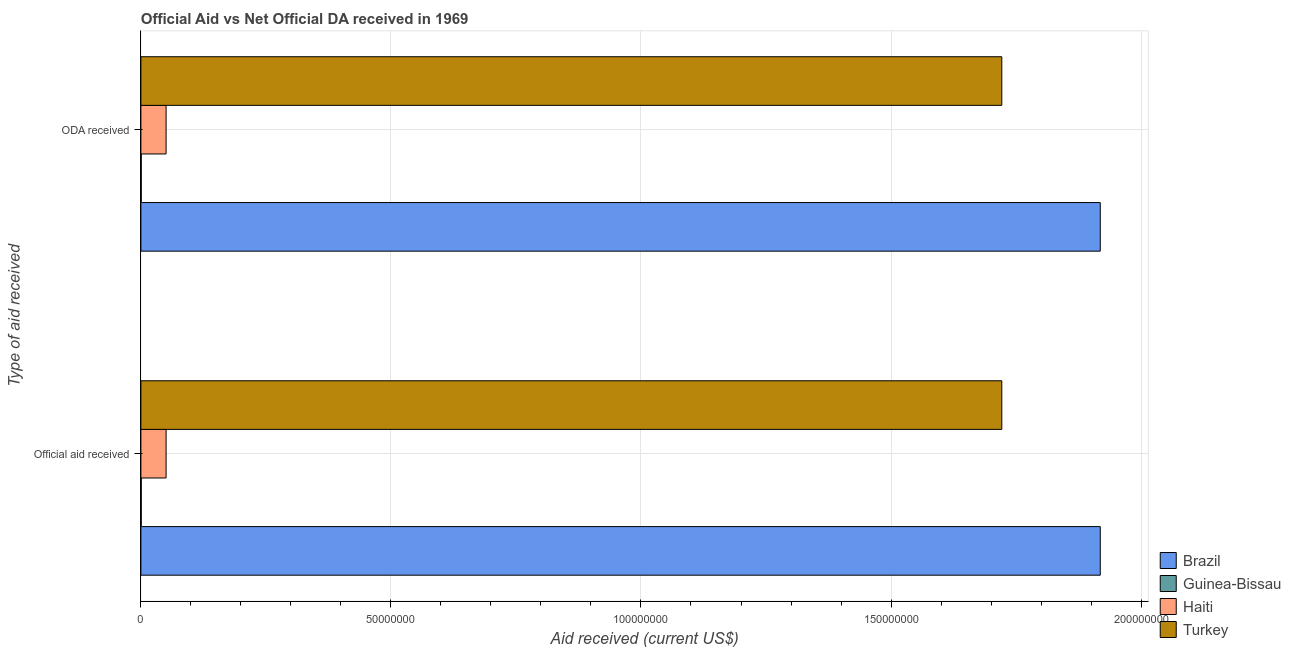How many different coloured bars are there?
Your response must be concise. 4. How many groups of bars are there?
Keep it short and to the point. 2. What is the label of the 2nd group of bars from the top?
Make the answer very short. Official aid received. What is the official aid received in Turkey?
Offer a very short reply. 1.72e+08. Across all countries, what is the maximum oda received?
Keep it short and to the point. 1.92e+08. Across all countries, what is the minimum official aid received?
Offer a very short reply. 7.00e+04. In which country was the oda received minimum?
Your response must be concise. Guinea-Bissau. What is the total oda received in the graph?
Keep it short and to the point. 3.69e+08. What is the difference between the official aid received in Guinea-Bissau and that in Brazil?
Your response must be concise. -1.92e+08. What is the difference between the oda received in Brazil and the official aid received in Haiti?
Your answer should be very brief. 1.87e+08. What is the average official aid received per country?
Offer a very short reply. 9.23e+07. In how many countries, is the oda received greater than 40000000 US$?
Your response must be concise. 2. What is the ratio of the official aid received in Turkey to that in Guinea-Bissau?
Provide a short and direct response. 2459.29. What does the 3rd bar from the top in ODA received represents?
Give a very brief answer. Guinea-Bissau. What does the 3rd bar from the bottom in ODA received represents?
Offer a very short reply. Haiti. How many bars are there?
Ensure brevity in your answer.  8. Are all the bars in the graph horizontal?
Make the answer very short. Yes. Does the graph contain grids?
Your answer should be very brief. Yes. Where does the legend appear in the graph?
Make the answer very short. Bottom right. How many legend labels are there?
Ensure brevity in your answer.  4. What is the title of the graph?
Ensure brevity in your answer.  Official Aid vs Net Official DA received in 1969 . Does "Uzbekistan" appear as one of the legend labels in the graph?
Your answer should be very brief. No. What is the label or title of the X-axis?
Give a very brief answer. Aid received (current US$). What is the label or title of the Y-axis?
Offer a very short reply. Type of aid received. What is the Aid received (current US$) of Brazil in Official aid received?
Provide a short and direct response. 1.92e+08. What is the Aid received (current US$) in Haiti in Official aid received?
Offer a terse response. 5.04e+06. What is the Aid received (current US$) in Turkey in Official aid received?
Your answer should be very brief. 1.72e+08. What is the Aid received (current US$) in Brazil in ODA received?
Your answer should be very brief. 1.92e+08. What is the Aid received (current US$) of Guinea-Bissau in ODA received?
Your response must be concise. 7.00e+04. What is the Aid received (current US$) of Haiti in ODA received?
Offer a very short reply. 5.04e+06. What is the Aid received (current US$) in Turkey in ODA received?
Your response must be concise. 1.72e+08. Across all Type of aid received, what is the maximum Aid received (current US$) in Brazil?
Give a very brief answer. 1.92e+08. Across all Type of aid received, what is the maximum Aid received (current US$) of Haiti?
Your answer should be very brief. 5.04e+06. Across all Type of aid received, what is the maximum Aid received (current US$) of Turkey?
Keep it short and to the point. 1.72e+08. Across all Type of aid received, what is the minimum Aid received (current US$) of Brazil?
Provide a short and direct response. 1.92e+08. Across all Type of aid received, what is the minimum Aid received (current US$) in Haiti?
Your response must be concise. 5.04e+06. Across all Type of aid received, what is the minimum Aid received (current US$) in Turkey?
Provide a succinct answer. 1.72e+08. What is the total Aid received (current US$) in Brazil in the graph?
Offer a terse response. 3.84e+08. What is the total Aid received (current US$) in Guinea-Bissau in the graph?
Your answer should be compact. 1.40e+05. What is the total Aid received (current US$) in Haiti in the graph?
Offer a very short reply. 1.01e+07. What is the total Aid received (current US$) of Turkey in the graph?
Your response must be concise. 3.44e+08. What is the difference between the Aid received (current US$) in Haiti in Official aid received and that in ODA received?
Ensure brevity in your answer.  0. What is the difference between the Aid received (current US$) in Brazil in Official aid received and the Aid received (current US$) in Guinea-Bissau in ODA received?
Keep it short and to the point. 1.92e+08. What is the difference between the Aid received (current US$) of Brazil in Official aid received and the Aid received (current US$) of Haiti in ODA received?
Offer a very short reply. 1.87e+08. What is the difference between the Aid received (current US$) of Brazil in Official aid received and the Aid received (current US$) of Turkey in ODA received?
Provide a succinct answer. 1.97e+07. What is the difference between the Aid received (current US$) in Guinea-Bissau in Official aid received and the Aid received (current US$) in Haiti in ODA received?
Provide a short and direct response. -4.97e+06. What is the difference between the Aid received (current US$) in Guinea-Bissau in Official aid received and the Aid received (current US$) in Turkey in ODA received?
Keep it short and to the point. -1.72e+08. What is the difference between the Aid received (current US$) in Haiti in Official aid received and the Aid received (current US$) in Turkey in ODA received?
Offer a very short reply. -1.67e+08. What is the average Aid received (current US$) of Brazil per Type of aid received?
Keep it short and to the point. 1.92e+08. What is the average Aid received (current US$) of Guinea-Bissau per Type of aid received?
Provide a succinct answer. 7.00e+04. What is the average Aid received (current US$) in Haiti per Type of aid received?
Offer a terse response. 5.04e+06. What is the average Aid received (current US$) in Turkey per Type of aid received?
Ensure brevity in your answer.  1.72e+08. What is the difference between the Aid received (current US$) in Brazil and Aid received (current US$) in Guinea-Bissau in Official aid received?
Offer a very short reply. 1.92e+08. What is the difference between the Aid received (current US$) of Brazil and Aid received (current US$) of Haiti in Official aid received?
Provide a succinct answer. 1.87e+08. What is the difference between the Aid received (current US$) in Brazil and Aid received (current US$) in Turkey in Official aid received?
Your answer should be very brief. 1.97e+07. What is the difference between the Aid received (current US$) in Guinea-Bissau and Aid received (current US$) in Haiti in Official aid received?
Keep it short and to the point. -4.97e+06. What is the difference between the Aid received (current US$) of Guinea-Bissau and Aid received (current US$) of Turkey in Official aid received?
Provide a short and direct response. -1.72e+08. What is the difference between the Aid received (current US$) of Haiti and Aid received (current US$) of Turkey in Official aid received?
Your answer should be very brief. -1.67e+08. What is the difference between the Aid received (current US$) in Brazil and Aid received (current US$) in Guinea-Bissau in ODA received?
Your answer should be compact. 1.92e+08. What is the difference between the Aid received (current US$) of Brazil and Aid received (current US$) of Haiti in ODA received?
Give a very brief answer. 1.87e+08. What is the difference between the Aid received (current US$) of Brazil and Aid received (current US$) of Turkey in ODA received?
Provide a short and direct response. 1.97e+07. What is the difference between the Aid received (current US$) in Guinea-Bissau and Aid received (current US$) in Haiti in ODA received?
Your response must be concise. -4.97e+06. What is the difference between the Aid received (current US$) of Guinea-Bissau and Aid received (current US$) of Turkey in ODA received?
Your answer should be very brief. -1.72e+08. What is the difference between the Aid received (current US$) in Haiti and Aid received (current US$) in Turkey in ODA received?
Your answer should be compact. -1.67e+08. What is the ratio of the Aid received (current US$) in Turkey in Official aid received to that in ODA received?
Keep it short and to the point. 1. What is the difference between the highest and the second highest Aid received (current US$) in Brazil?
Ensure brevity in your answer.  0. What is the difference between the highest and the second highest Aid received (current US$) of Haiti?
Make the answer very short. 0. 